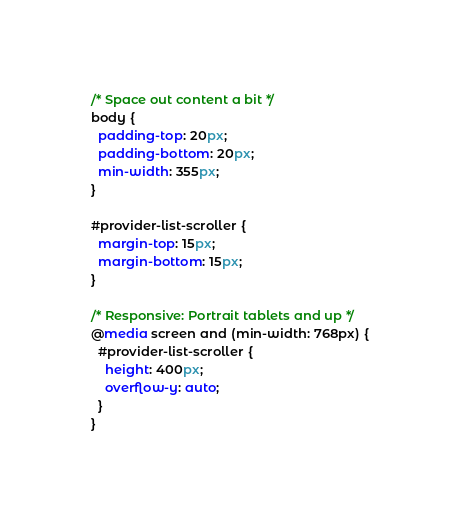<code> <loc_0><loc_0><loc_500><loc_500><_CSS_>/* Space out content a bit */
body {
  padding-top: 20px;
  padding-bottom: 20px;
  min-width: 355px;
}

#provider-list-scroller {
  margin-top: 15px;
  margin-bottom: 15px;
}

/* Responsive: Portrait tablets and up */
@media screen and (min-width: 768px) {
  #provider-list-scroller {
    height: 400px;
    overflow-y: auto;
  }
}
</code> 